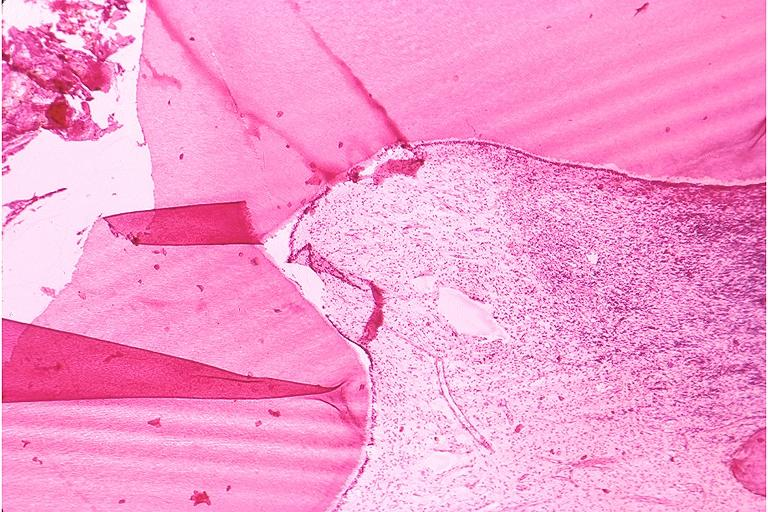what is present?
Answer the question using a single word or phrase. Oral 